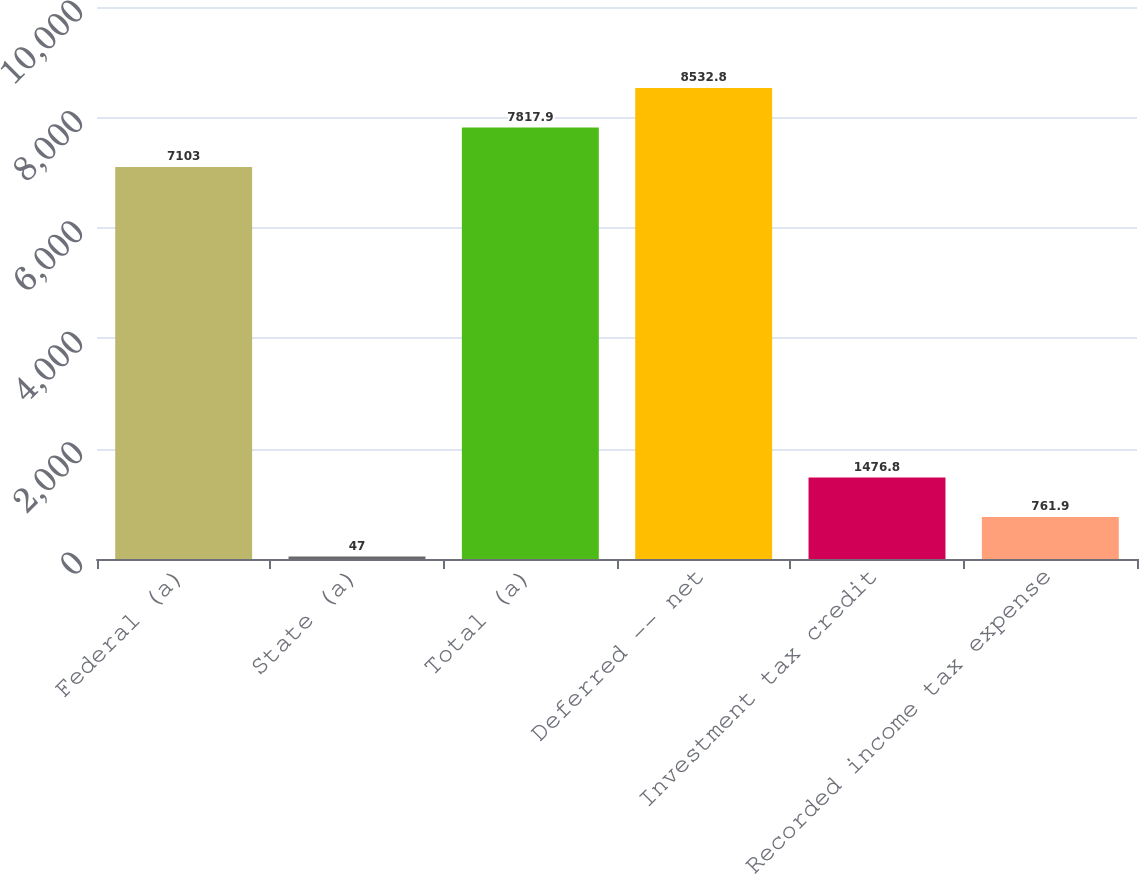Convert chart. <chart><loc_0><loc_0><loc_500><loc_500><bar_chart><fcel>Federal (a)<fcel>State (a)<fcel>Total (a)<fcel>Deferred -- net<fcel>Investment tax credit<fcel>Recorded income tax expense<nl><fcel>7103<fcel>47<fcel>7817.9<fcel>8532.8<fcel>1476.8<fcel>761.9<nl></chart> 